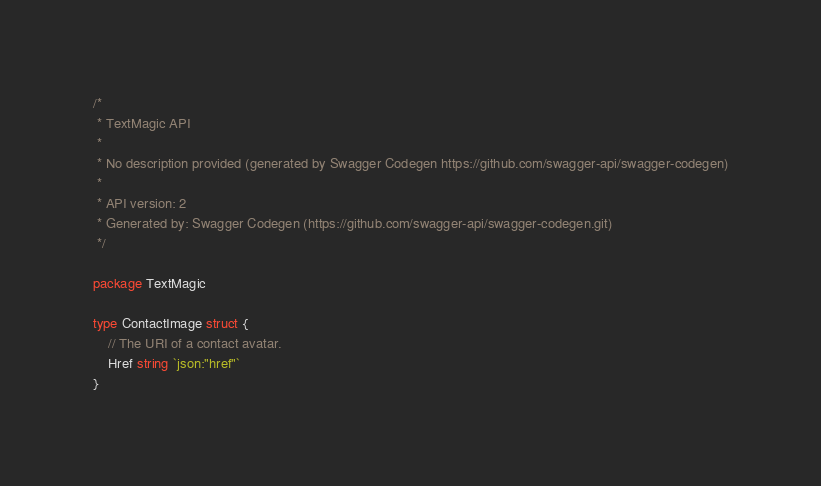<code> <loc_0><loc_0><loc_500><loc_500><_Go_>/*
 * TextMagic API
 *
 * No description provided (generated by Swagger Codegen https://github.com/swagger-api/swagger-codegen)
 *
 * API version: 2
 * Generated by: Swagger Codegen (https://github.com/swagger-api/swagger-codegen.git)
 */

package TextMagic

type ContactImage struct {
	// The URI of a contact avatar.
	Href string `json:"href"`
}
</code> 